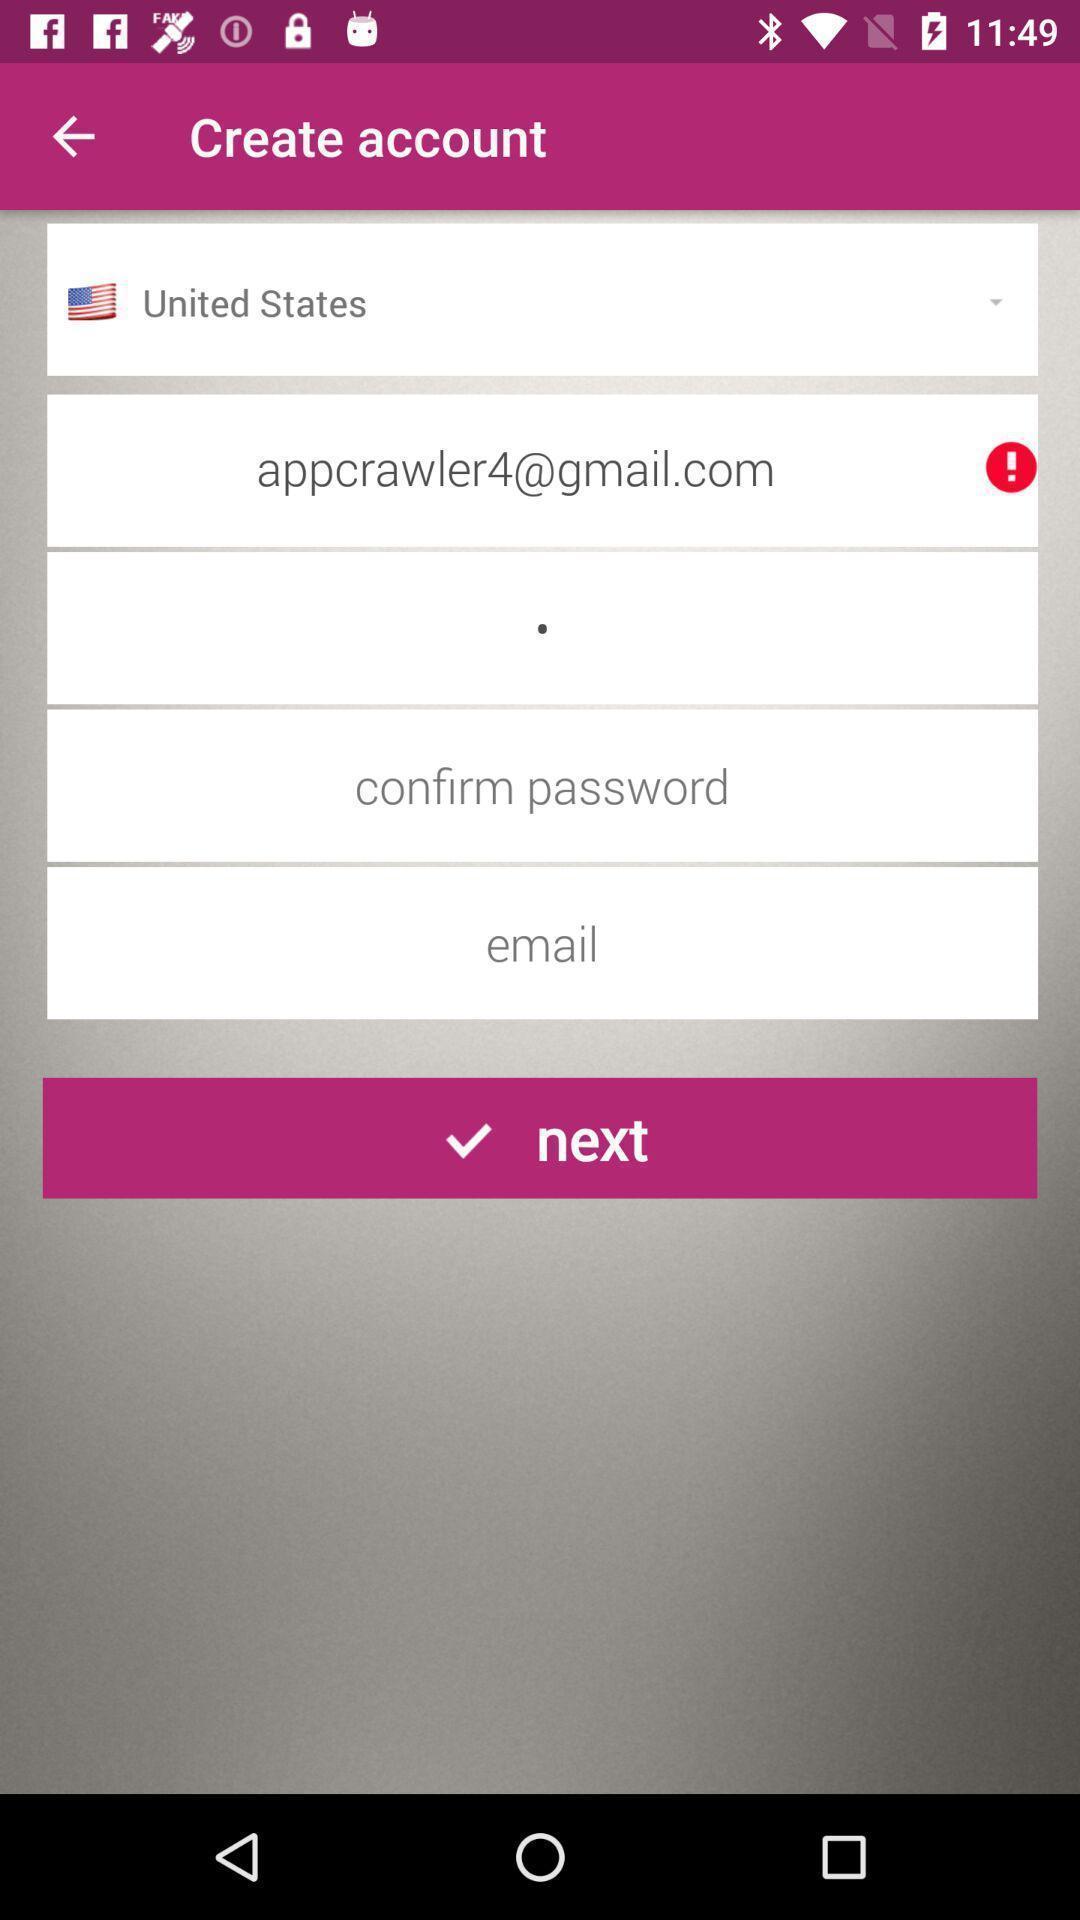Provide a textual representation of this image. Page displaying to create an account. 